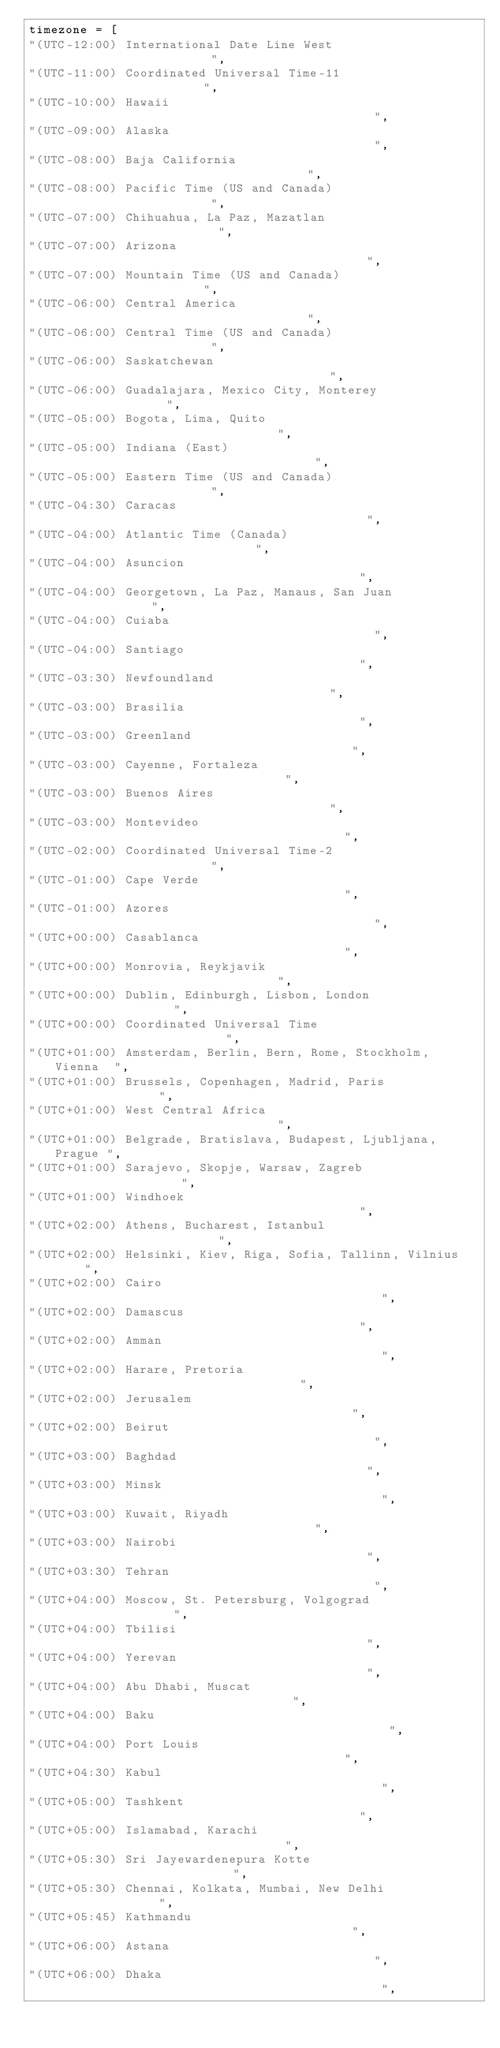Convert code to text. <code><loc_0><loc_0><loc_500><loc_500><_Python_>timezone = [
"(UTC-12:00) International Date Line West                      ",
"(UTC-11:00) Coordinated Universal Time-11                     ",
"(UTC-10:00) Hawaii                                            ",
"(UTC-09:00) Alaska                                            ",
"(UTC-08:00) Baja California                                   ",
"(UTC-08:00) Pacific Time (US and Canada)                      ",
"(UTC-07:00) Chihuahua, La Paz, Mazatlan                       ",
"(UTC-07:00) Arizona                                           ",
"(UTC-07:00) Mountain Time (US and Canada)                     ",
"(UTC-06:00) Central America                                   ",
"(UTC-06:00) Central Time (US and Canada)                      ",
"(UTC-06:00) Saskatchewan                                      ",
"(UTC-06:00) Guadalajara, Mexico City, Monterey                ",
"(UTC-05:00) Bogota, Lima, Quito                               ",
"(UTC-05:00) Indiana (East)                                    ",
"(UTC-05:00) Eastern Time (US and Canada)                      ",
"(UTC-04:30) Caracas                                           ",
"(UTC-04:00) Atlantic Time (Canada)                            ",
"(UTC-04:00) Asuncion                                          ",
"(UTC-04:00) Georgetown, La Paz, Manaus, San Juan              ",
"(UTC-04:00) Cuiaba                                            ",
"(UTC-04:00) Santiago                                          ",
"(UTC-03:30) Newfoundland                                      ",
"(UTC-03:00) Brasilia                                          ",
"(UTC-03:00) Greenland                                         ",
"(UTC-03:00) Cayenne, Fortaleza                                ",
"(UTC-03:00) Buenos Aires                                      ",
"(UTC-03:00) Montevideo                                        ",
"(UTC-02:00) Coordinated Universal Time-2                      ",
"(UTC-01:00) Cape Verde                                        ",
"(UTC-01:00) Azores                                            ",
"(UTC+00:00) Casablanca                                        ",
"(UTC+00:00) Monrovia, Reykjavik                               ",
"(UTC+00:00) Dublin, Edinburgh, Lisbon, London                 ",
"(UTC+00:00) Coordinated Universal Time                        ",
"(UTC+01:00) Amsterdam, Berlin, Bern, Rome, Stockholm, Vienna  ",
"(UTC+01:00) Brussels, Copenhagen, Madrid, Paris               ",
"(UTC+01:00) West Central Africa                               ",
"(UTC+01:00) Belgrade, Bratislava, Budapest, Ljubljana, Prague ",
"(UTC+01:00) Sarajevo, Skopje, Warsaw, Zagreb                  ",
"(UTC+01:00) Windhoek                                          ",
"(UTC+02:00) Athens, Bucharest, Istanbul                       ",
"(UTC+02:00) Helsinki, Kiev, Riga, Sofia, Tallinn, Vilnius     ",
"(UTC+02:00) Cairo                                             ",
"(UTC+02:00) Damascus                                          ",
"(UTC+02:00) Amman                                             ",
"(UTC+02:00) Harare, Pretoria                                  ",
"(UTC+02:00) Jerusalem                                         ",
"(UTC+02:00) Beirut                                            ",
"(UTC+03:00) Baghdad                                           ",
"(UTC+03:00) Minsk                                             ",
"(UTC+03:00) Kuwait, Riyadh                                    ",
"(UTC+03:00) Nairobi                                           ",
"(UTC+03:30) Tehran                                            ",
"(UTC+04:00) Moscow, St. Petersburg, Volgograd                 ",
"(UTC+04:00) Tbilisi                                           ",
"(UTC+04:00) Yerevan                                           ",
"(UTC+04:00) Abu Dhabi, Muscat                                 ",
"(UTC+04:00) Baku                                              ",
"(UTC+04:00) Port Louis                                        ",
"(UTC+04:30) Kabul                                             ",
"(UTC+05:00) Tashkent                                          ",
"(UTC+05:00) Islamabad, Karachi                                ",
"(UTC+05:30) Sri Jayewardenepura Kotte                         ",
"(UTC+05:30) Chennai, Kolkata, Mumbai, New Delhi               ",
"(UTC+05:45) Kathmandu                                         ",
"(UTC+06:00) Astana                                            ",
"(UTC+06:00) Dhaka                                             ",</code> 